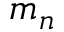<formula> <loc_0><loc_0><loc_500><loc_500>m _ { n }</formula> 